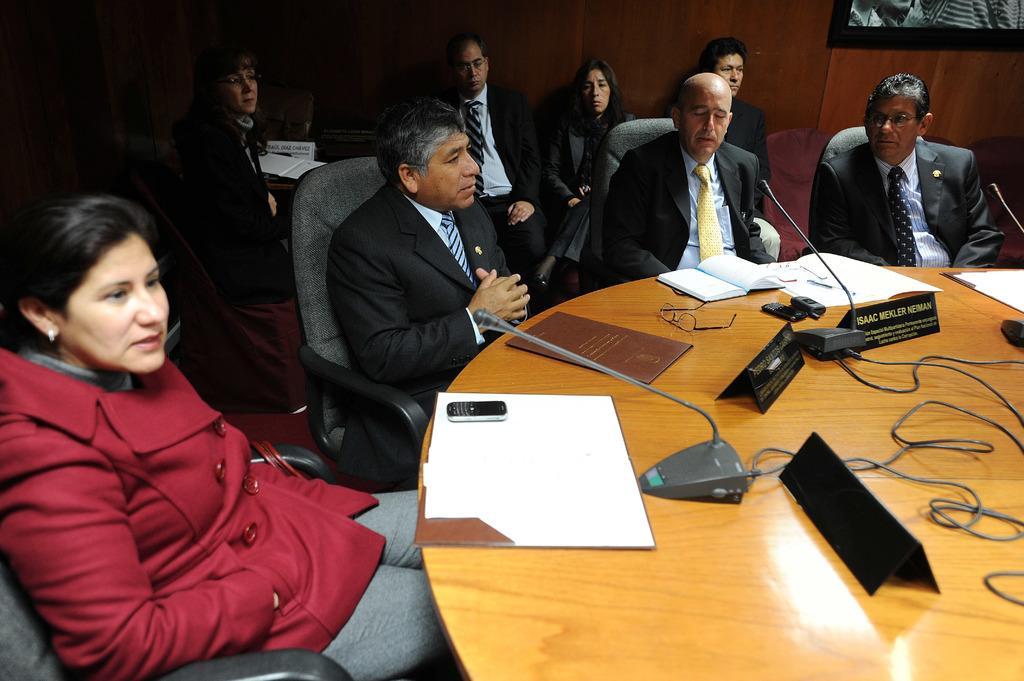Please provide a concise description of this image. This image is clicked in a room where there is a table and chairs. There are people sitting on chairs near the table. On the table there are files, books, papers, mobile phones, name boards, wires, mic. On the top right corner there is a photo frame. 